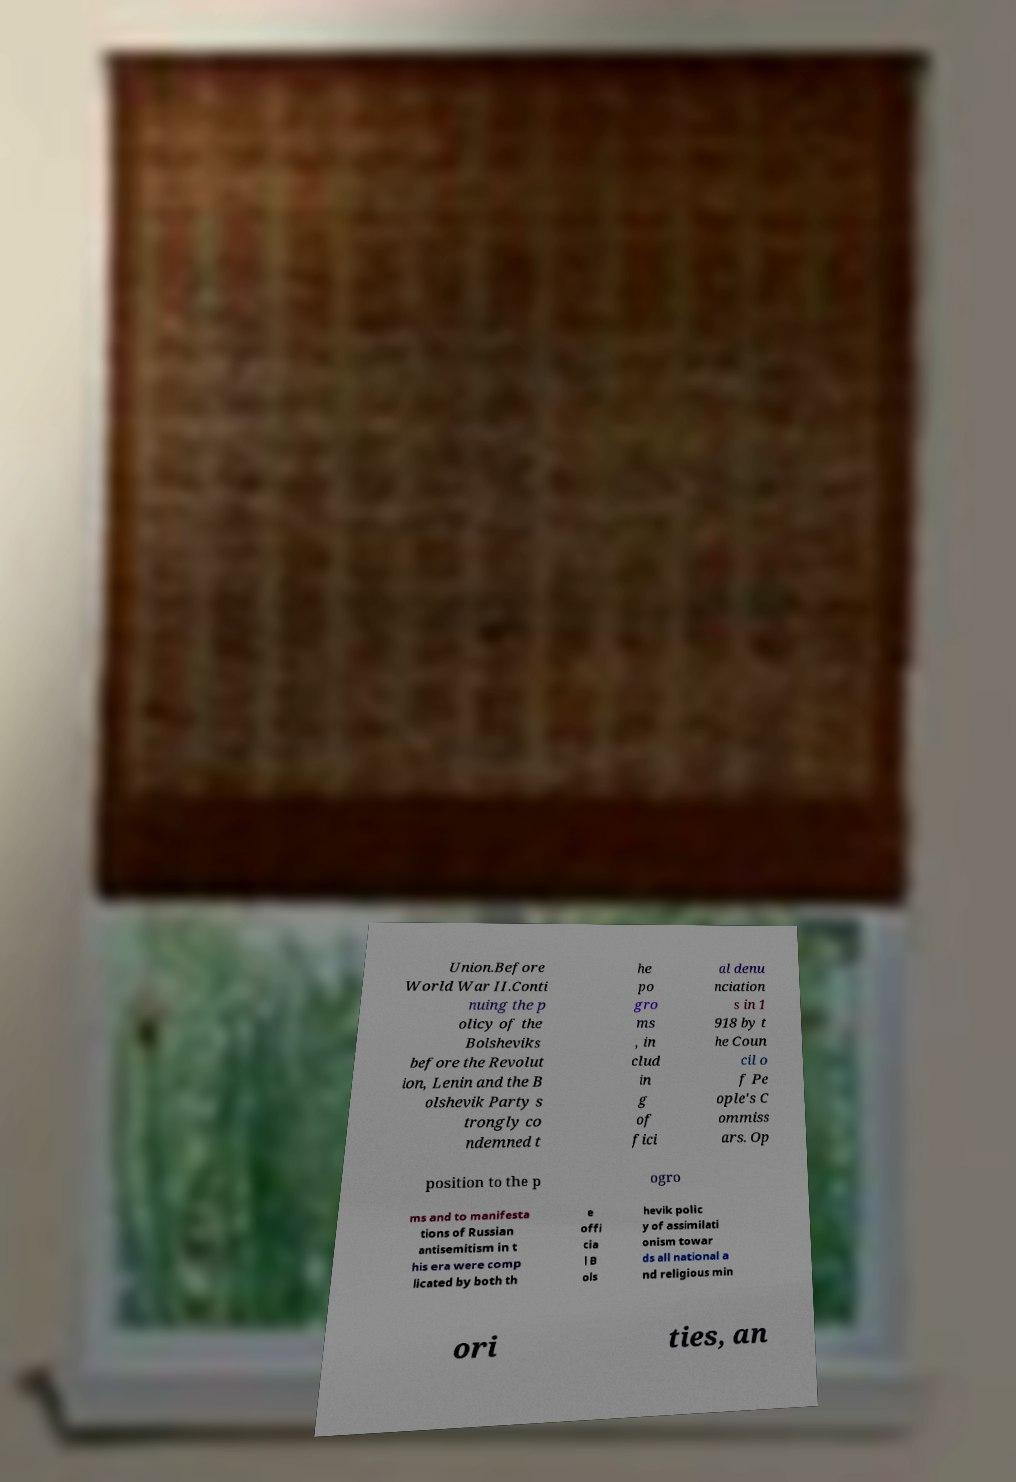Can you accurately transcribe the text from the provided image for me? Union.Before World War II.Conti nuing the p olicy of the Bolsheviks before the Revolut ion, Lenin and the B olshevik Party s trongly co ndemned t he po gro ms , in clud in g of fici al denu nciation s in 1 918 by t he Coun cil o f Pe ople's C ommiss ars. Op position to the p ogro ms and to manifesta tions of Russian antisemitism in t his era were comp licated by both th e offi cia l B ols hevik polic y of assimilati onism towar ds all national a nd religious min ori ties, an 